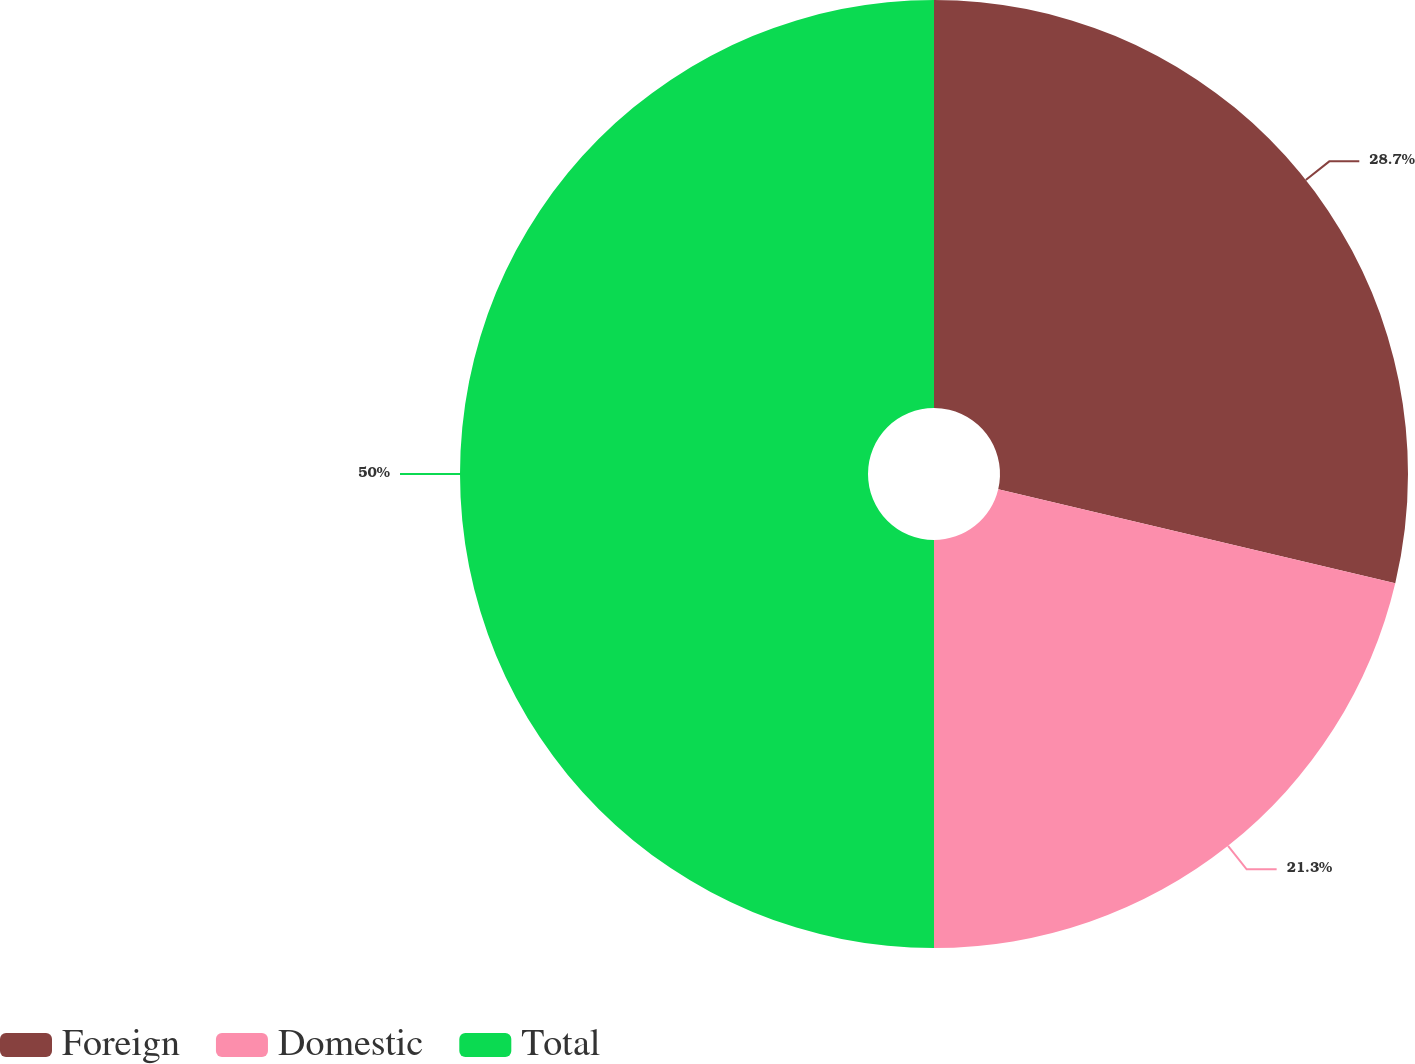Convert chart. <chart><loc_0><loc_0><loc_500><loc_500><pie_chart><fcel>Foreign<fcel>Domestic<fcel>Total<nl><fcel>28.7%<fcel>21.3%<fcel>50.0%<nl></chart> 